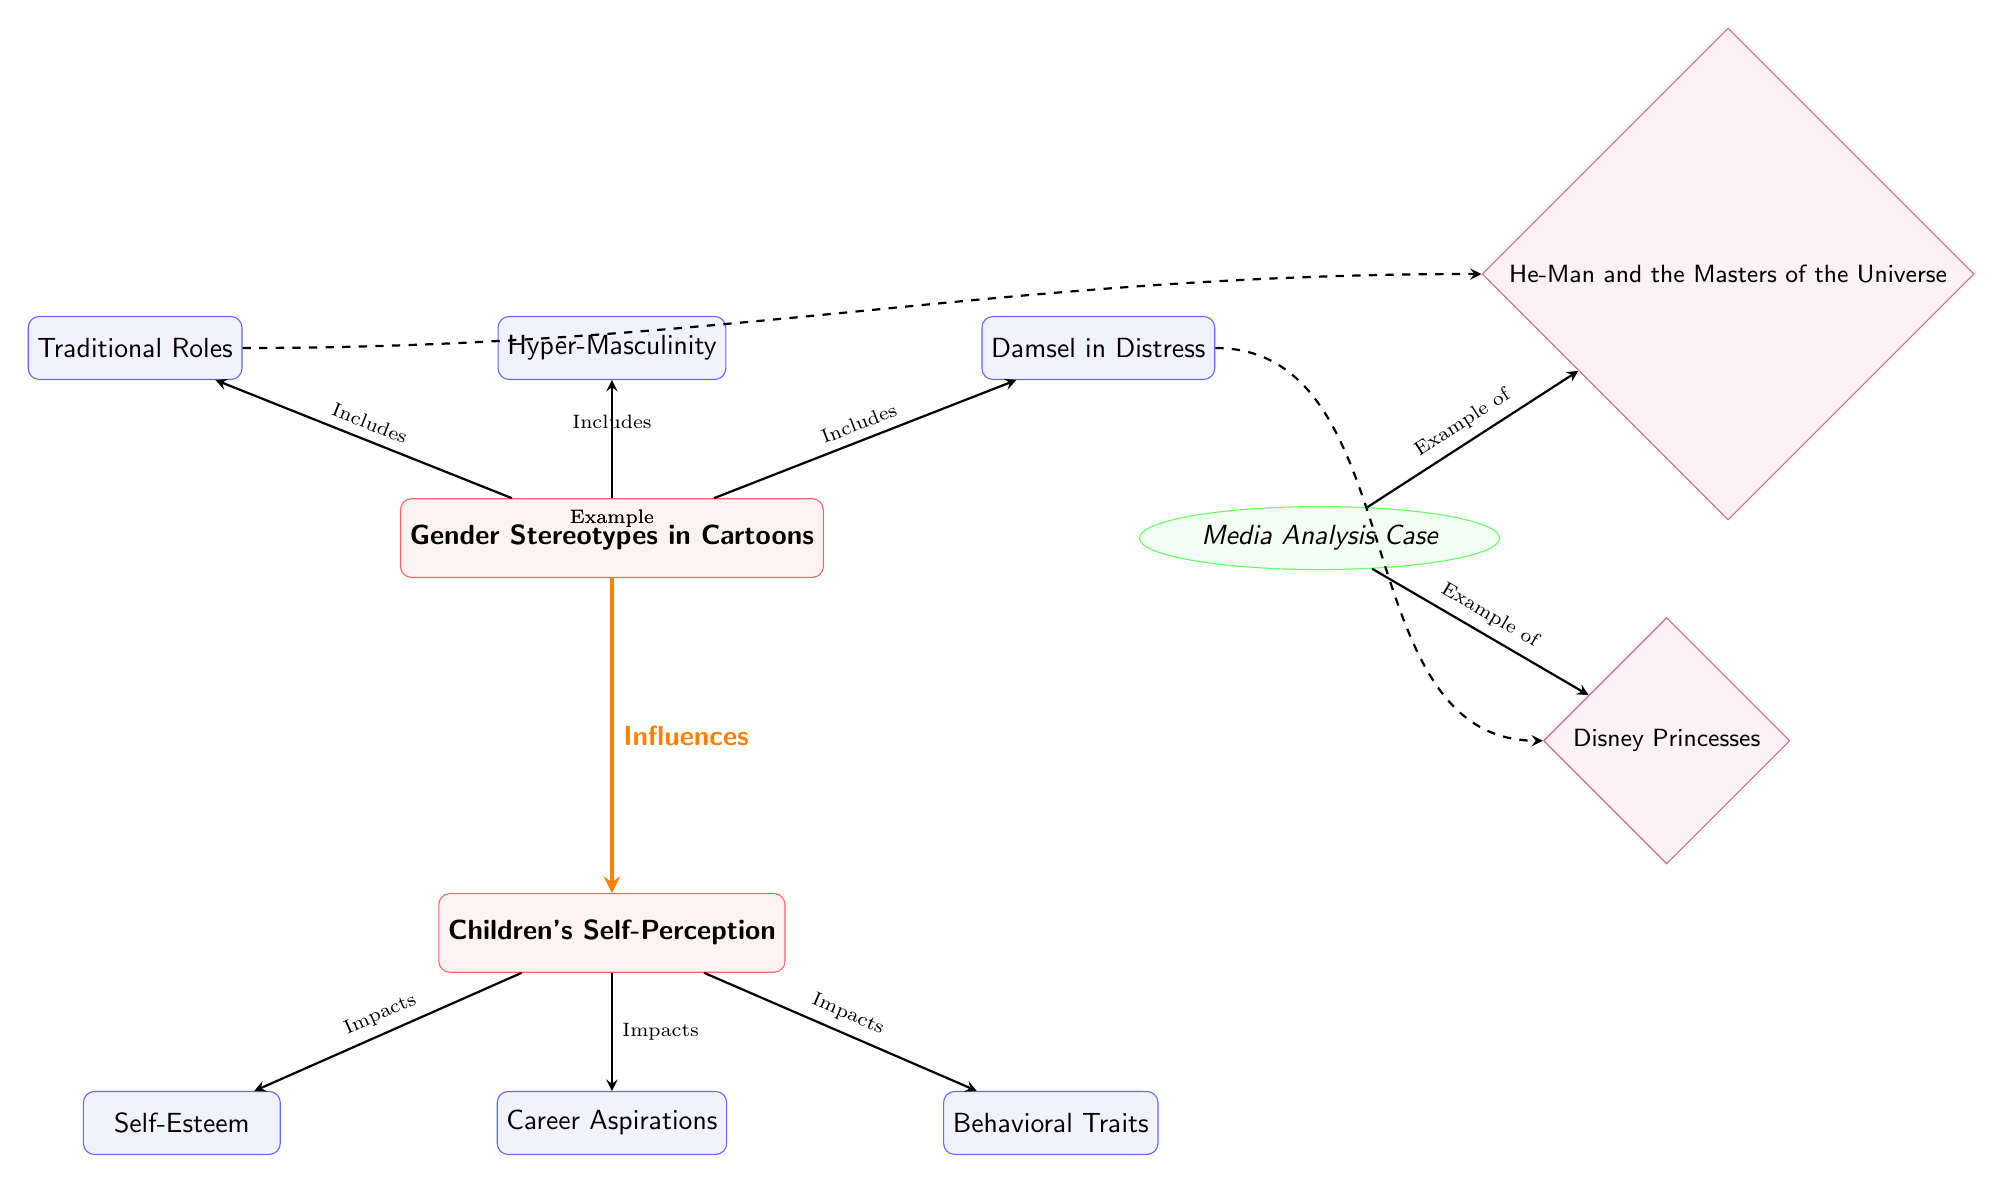What are the main topics of the diagram? The main topics are "Gender Stereotypes in Cartoons" and "Children's Self-Perception." They are represented as large rectangles at the top and bottom of the diagram, respectively. These main topics define the overall theme of the diagram.
Answer: Gender Stereotypes in Cartoons, Children's Self-Perception How many subtopics are listed under "Gender Stereotypes in Cartoons"? There are three subtopics listed under "Gender Stereotypes in Cartoons": "Traditional Roles," "Hyper-Masculinity," and "Damsel in Distress." Each of these is depicted as a smaller rectangle branching from the main topic.
Answer: Three What type of relationship exists between "Gender Stereotypes in Cartoons" and "Children's Self-Perception"? The relationship is indicated by an orange, ultra-thick arrow labeled "Influences." This shows that there is a causal or impactful relationship, where the former affects the latter.
Answer: Influences What does "Children's Self-Perception" impact according to the diagram? "Children's Self-Perception" impacts three areas: "Self-Esteem," "Career Aspirations," and "Behavioral Traits," as shown by the arrows extending from the self-perception box to each of these subtopics.
Answer: Self-Esteem, Career Aspirations, Behavioral Traits Which cartoon examples are provided in the diagram? The examples provided are "He-Man and the Masters of the Universe" and "Disney Princesses." They are shown as ellipse and diamond shapes connected to the "Media Analysis Case" node, representing specific instances of gender stereotypes in cartoons.
Answer: He-Man and the Masters of the Universe, Disney Princesses What is the connection type between "Traditional Roles" and "He-Man and the Masters of the Universe"? The connection is shown as a dashed arrow labeled "Example," indicating that "He-Man and the Masters of the Universe" is an example of the "Traditional Roles" stereotype. This is a specific connection between a subtopic and an illustrative example.
Answer: Example How many impacts arise from "Children's Self-Perception"? There are three impacts arising from "Children's Self-Perception," which are represented by arrows pointing toward their respective subtopics in the diagram. This reflects the influence of self-perception on multiple aspects of a child's development.
Answer: Three What is the subtopic related to "Damsel in Distress"? The subtopic related to "Damsel in Distress" is specifically connected to an example, which is "Disney Princesses." The arrow indicates that this portrayal in cartoons exemplifies the stereotypical "Damsel in Distress" character.
Answer: Disney Princesses 